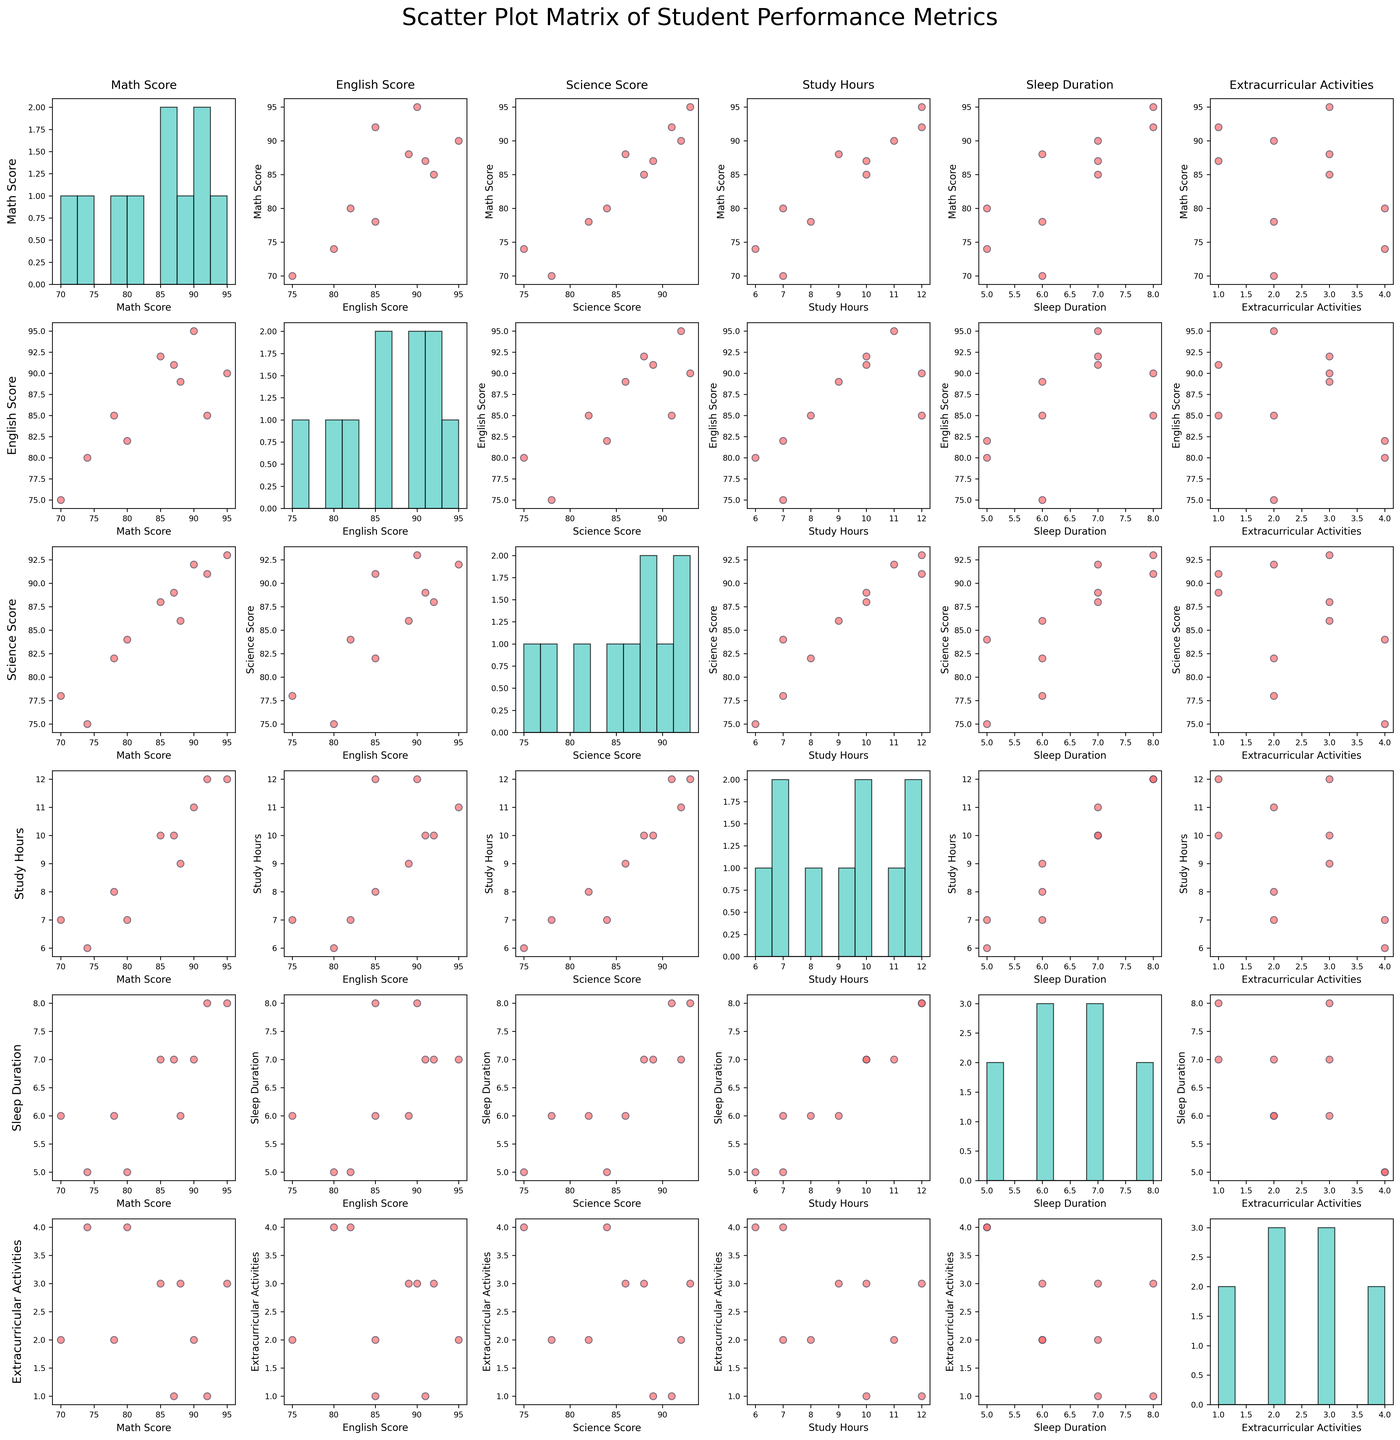**Basic Question**
What's the title of the figure? The title of the figure is located at the top center. It reads "Scatter Plot Matrix of Student Performance Metrics."
Answer: Scatter Plot Matrix of Student Performance Metrics **Compositional Question**
What's the average Study_Hours for Alice and Charlie? To find the average Study_Hours for Alice and Charlie, sum their Study_Hours (10 + 12) and then divide by the number of students, which is 2. This gives (10 + 12) / 2 = 11.
Answer: 11 **Comparison Question**
Who has a higher Math_Score, Alice or Bob? Compare Alice's Math_Score (85) with Bob's Math_Score (78). Since 85 is greater than 78, Alice has the higher Math_Score.
Answer: Alice **Chart-Type Specific Question**
Which pair of metrics shows a clear positive correlation in the scatter plot matrix? From the scatter plot matrix, observe the scatter plots of different metric pairs. A clear positive correlation is noticed between Study_Hours and Math_Score since points tend to rise together.
Answer: Study_Hours and Math_Score **Basic Question**
How many data points are present in each scatter plot? Each scatter plot represents the individual scores and metrics of 10 students. Hence, there are 10 data points in each scatter plot.
Answer: 10 **Comparison Question**
Compare Sleep_Duration between Henry and Daniel. Who gets more sleep? Henry's Sleep_Duration is 8 hours, while Daniel's is 5 hours. Since 8 is greater than 5, Henry gets more sleep.
Answer: Henry **Compositional Question**
What's the total Extracurricular_Activities of all students? Sum the Extracurricular_Activities for all students (3 + 2 + 1 + 4 + 2 + 3 + 2 + 3 + 1 + 4). This gives 25.
Answer: 25 **Chart-Type Specific Question**
Is there any student whose scores in all subjects are above 90? By examining the diagonal histograms for Math_Score, English_Score, and Science_Score, we see that only Ella and Henry have individual scores in all subjects above 90.
Answer: Ella, Henry **Comparison Question**
Who has a higher English_Score, Ella or Fiona? Compare Ella's English_Score (95) with Fiona's English_Score (89). Since 95 is greater than 89, Ella has the higher English_Score.
Answer: Ella **Compositional Question**
What's the difference in total Study_Hours between students with 3 Extracurricular_Activities and those with 1 or 2? Sum Study_Hours for students with 3 activities (Alice, Fiona, Henry; 10 + 9 + 12 = 31). Sum Study_Hours for students with 1 or 2 activities (Bob, Charlie, Ella, George, Isabella; 8 + 12 + 11 + 7 + 10 = 48). The difference is 48 - 31 = 17.
Answer: 17 